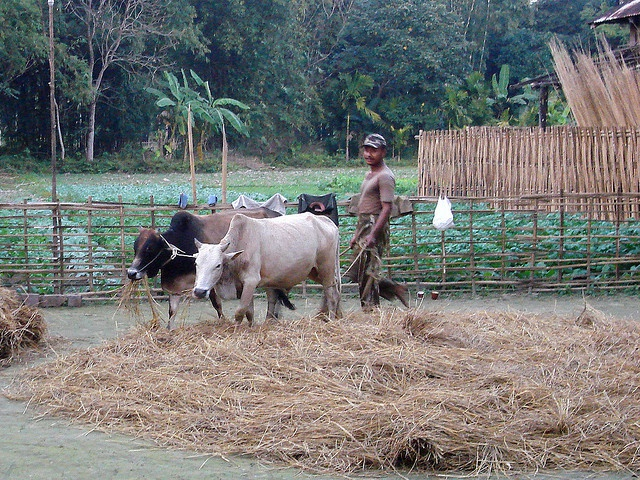Describe the objects in this image and their specific colors. I can see cow in gray, darkgray, and lavender tones, cow in gray, black, and darkgray tones, and people in gray, black, and darkgray tones in this image. 